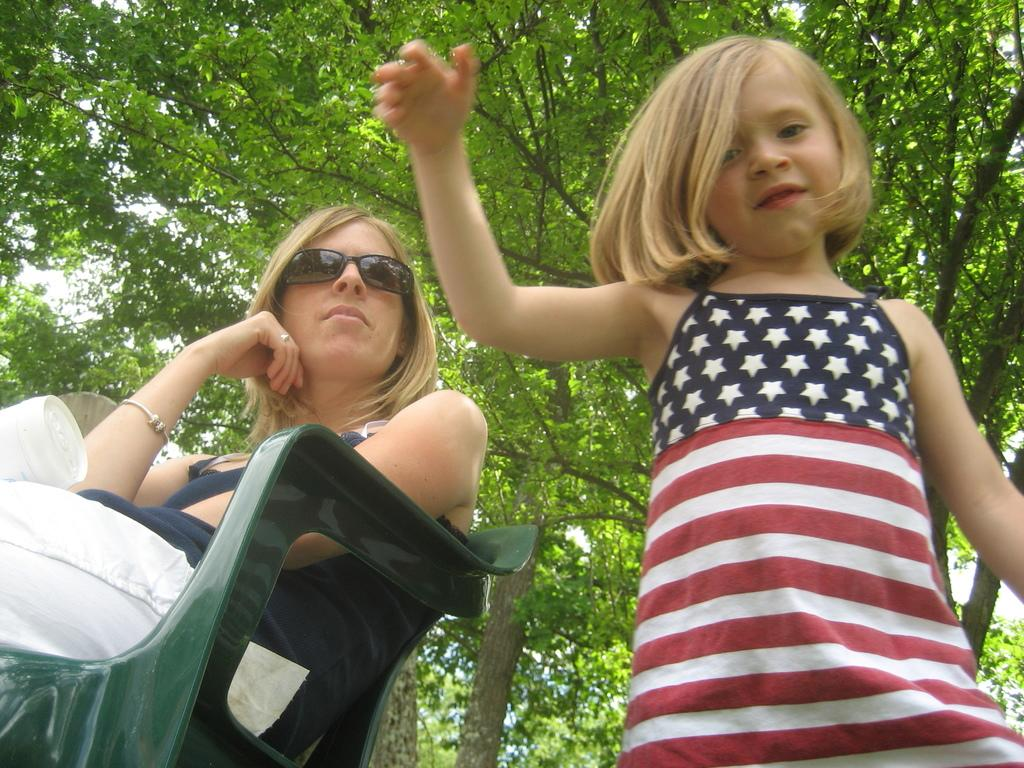Who is present in the image? There is a woman and a kid in the image. What can be seen in the background of the image? Trees are visible in the background of the image. What type of store can be seen in the image? There is no store present in the image; it features a woman and a kid with trees in the background. Is there a kite being flown by the kid in the image? There is no kite visible in the image. 